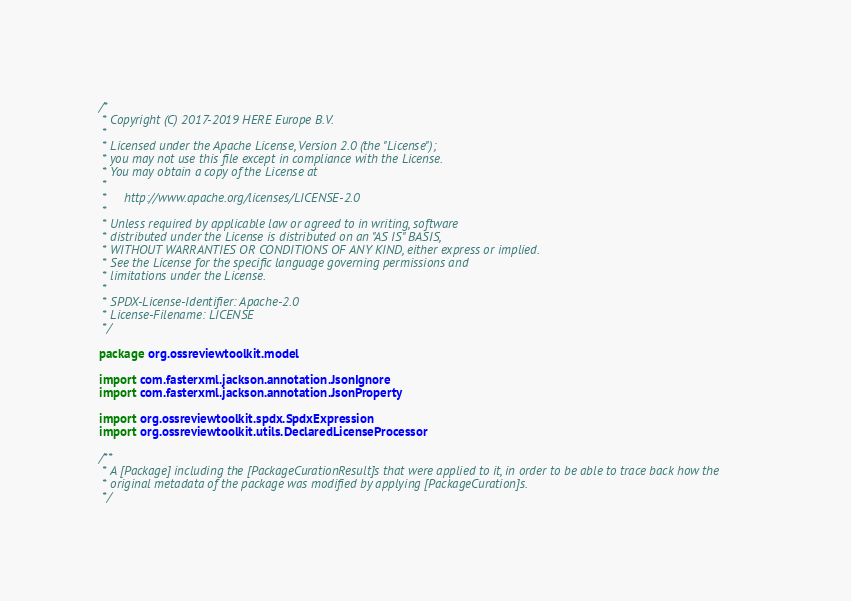<code> <loc_0><loc_0><loc_500><loc_500><_Kotlin_>/*
 * Copyright (C) 2017-2019 HERE Europe B.V.
 *
 * Licensed under the Apache License, Version 2.0 (the "License");
 * you may not use this file except in compliance with the License.
 * You may obtain a copy of the License at
 *
 *     http://www.apache.org/licenses/LICENSE-2.0
 *
 * Unless required by applicable law or agreed to in writing, software
 * distributed under the License is distributed on an "AS IS" BASIS,
 * WITHOUT WARRANTIES OR CONDITIONS OF ANY KIND, either express or implied.
 * See the License for the specific language governing permissions and
 * limitations under the License.
 *
 * SPDX-License-Identifier: Apache-2.0
 * License-Filename: LICENSE
 */

package org.ossreviewtoolkit.model

import com.fasterxml.jackson.annotation.JsonIgnore
import com.fasterxml.jackson.annotation.JsonProperty

import org.ossreviewtoolkit.spdx.SpdxExpression
import org.ossreviewtoolkit.utils.DeclaredLicenseProcessor

/**
 * A [Package] including the [PackageCurationResult]s that were applied to it, in order to be able to trace back how the
 * original metadata of the package was modified by applying [PackageCuration]s.
 */</code> 